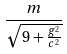<formula> <loc_0><loc_0><loc_500><loc_500>\frac { m } { \sqrt { 9 + \frac { g ^ { 2 } } { c ^ { 2 } } } }</formula> 